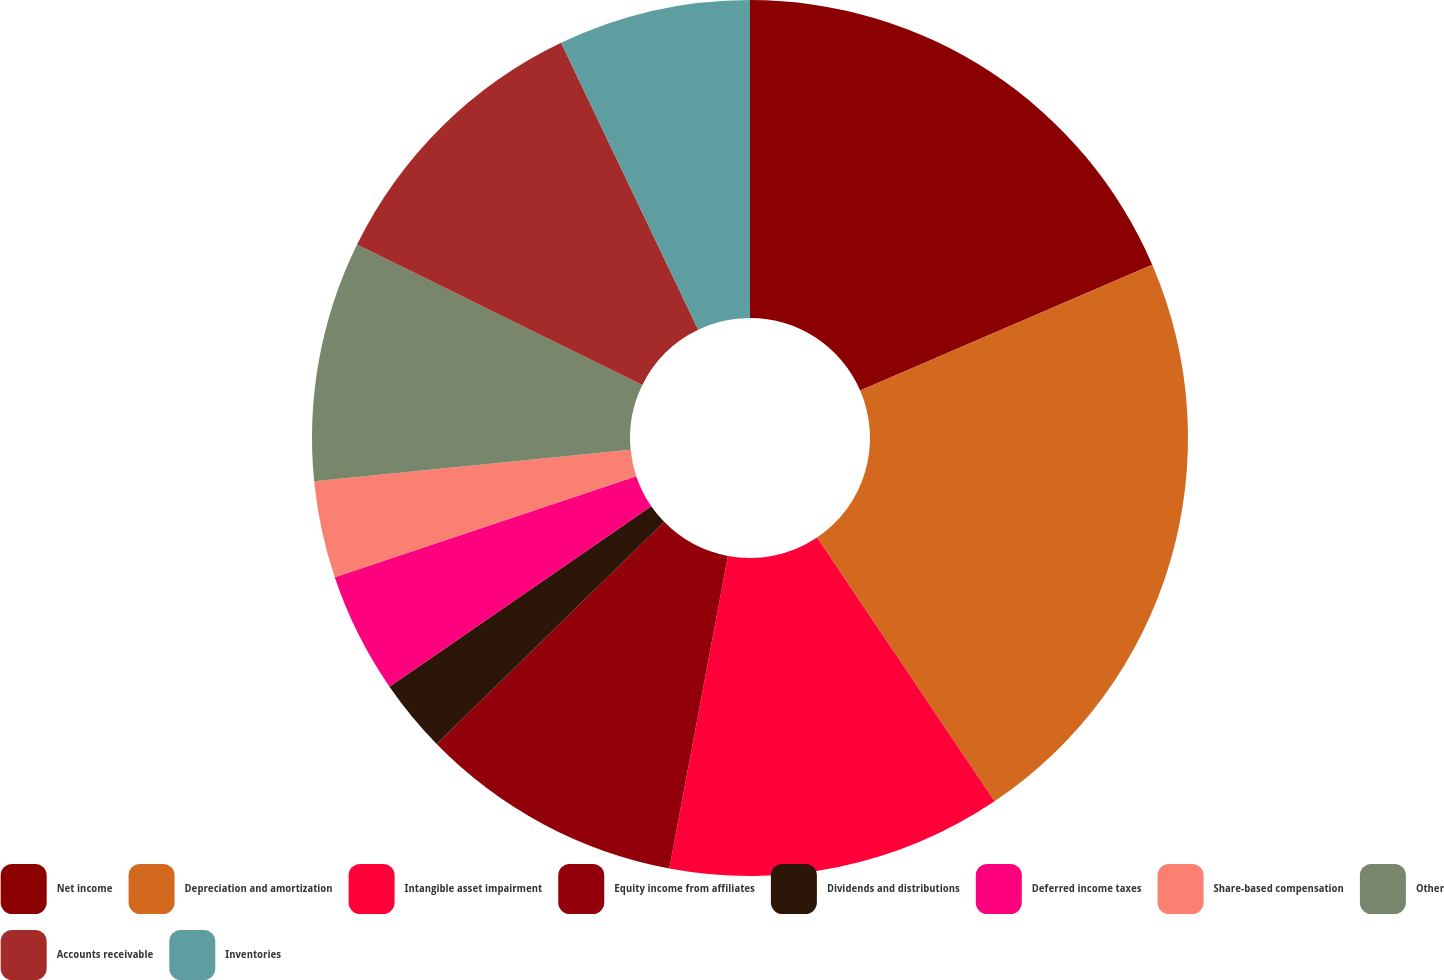<chart> <loc_0><loc_0><loc_500><loc_500><pie_chart><fcel>Net income<fcel>Depreciation and amortization<fcel>Intangible asset impairment<fcel>Equity income from affiliates<fcel>Dividends and distributions<fcel>Deferred income taxes<fcel>Share-based compensation<fcel>Other<fcel>Accounts receivable<fcel>Inventories<nl><fcel>18.53%<fcel>22.05%<fcel>12.38%<fcel>9.74%<fcel>2.7%<fcel>4.46%<fcel>3.58%<fcel>8.86%<fcel>10.62%<fcel>7.1%<nl></chart> 